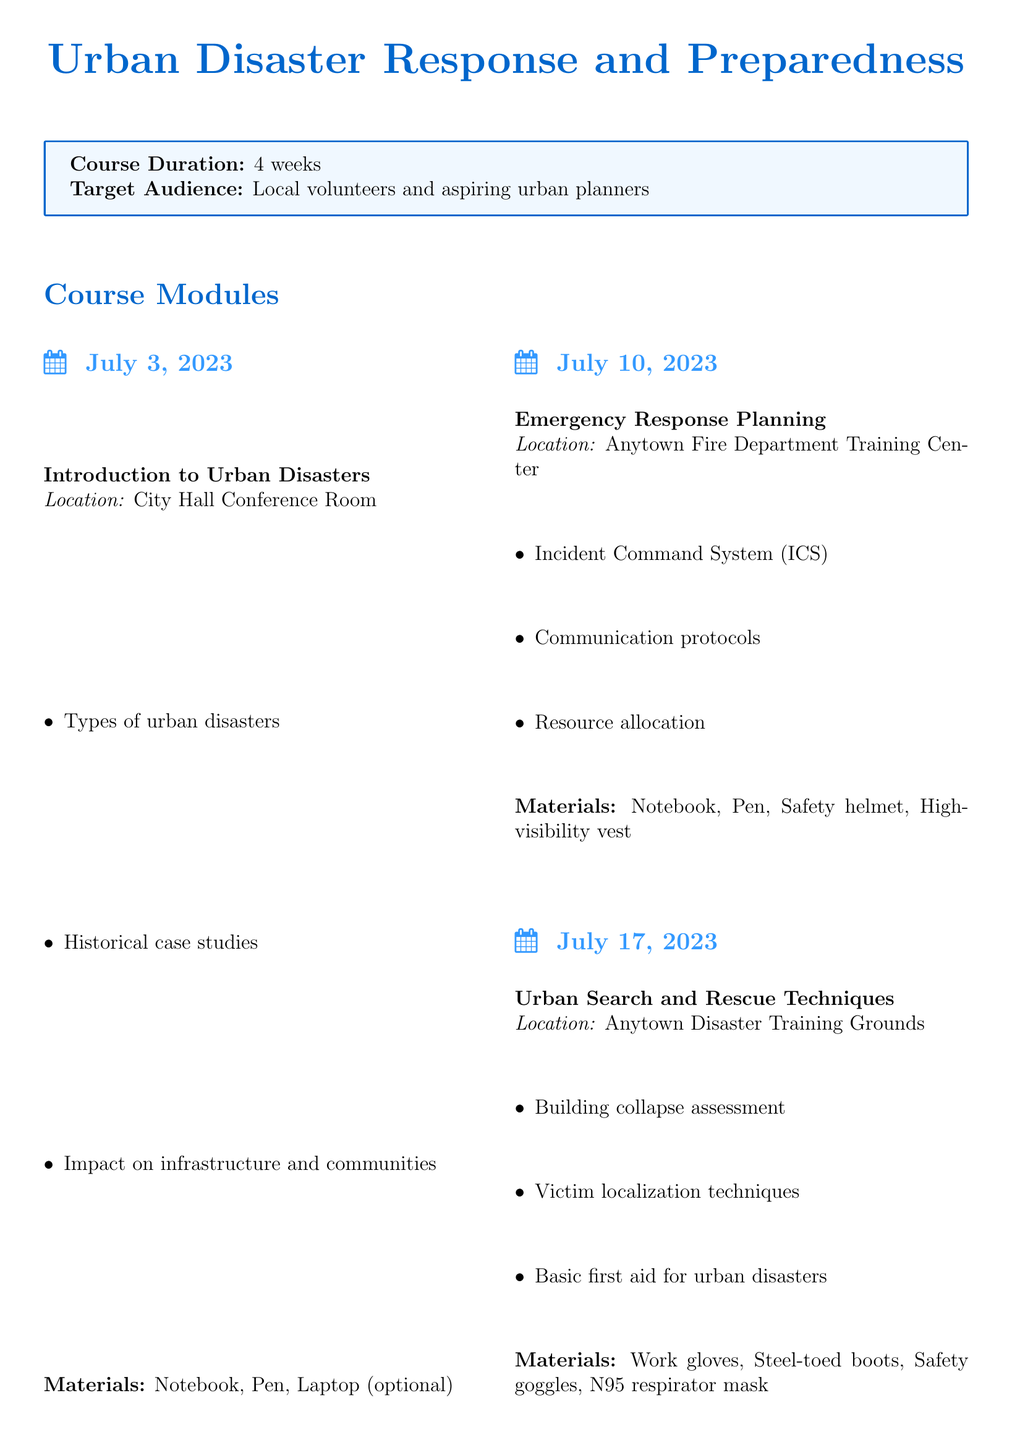What is the course title? The course title is specifically mentioned at the beginning of the document.
Answer: Urban Disaster Response and Preparedness How long is the course duration? The course duration is given as a specific time frame in the document.
Answer: 4 weeks What date is the "Emergency Response Planning" module scheduled for? The date for the "Emergency Response Planning" module is included in the module details.
Answer: July 10, 2023 Which location hosts the "Urban Search and Rescue Techniques" module? The location is specified in the details of each module within the document.
Answer: Anytown Disaster Training Grounds What materials are required for the "Community Resilience and Recovery" module? The required materials for each module are listed clearly in the document.
Answer: Notebook, Pen, Laptop with GIS software Who is the instructor for the course? The instructors are listed at the end of the document.
Answer: Dr. Sarah Johnson What is the final project title? The title of the final project is provided within the project section of the document.
Answer: Urban Disaster Response Plan What is the due date for the final project? The due date can be found in the description of the final project in the syllabus.
Answer: August 7, 2023 What specific expertise does Captain Michael Torres have? The expertise of each instructor is mentioned alongside their names in the document.
Answer: Emergency response coordination 